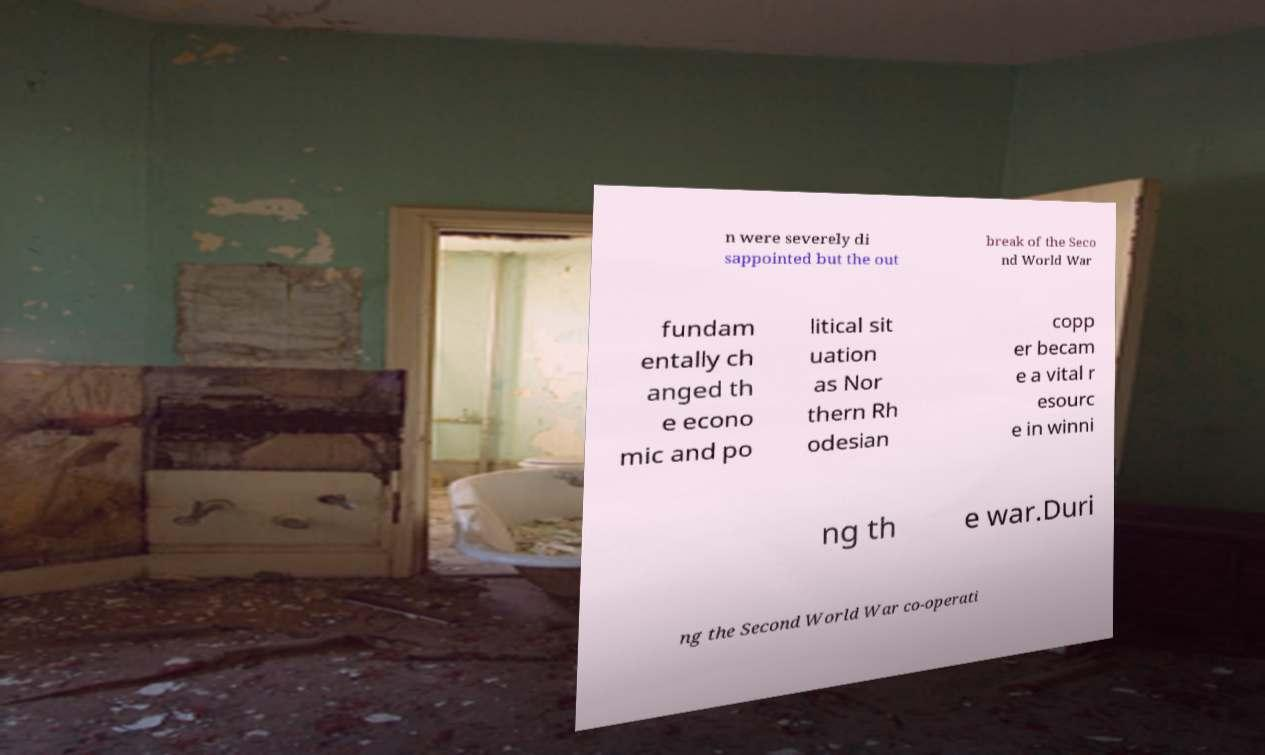Could you extract and type out the text from this image? n were severely di sappointed but the out break of the Seco nd World War fundam entally ch anged th e econo mic and po litical sit uation as Nor thern Rh odesian copp er becam e a vital r esourc e in winni ng th e war.Duri ng the Second World War co-operati 